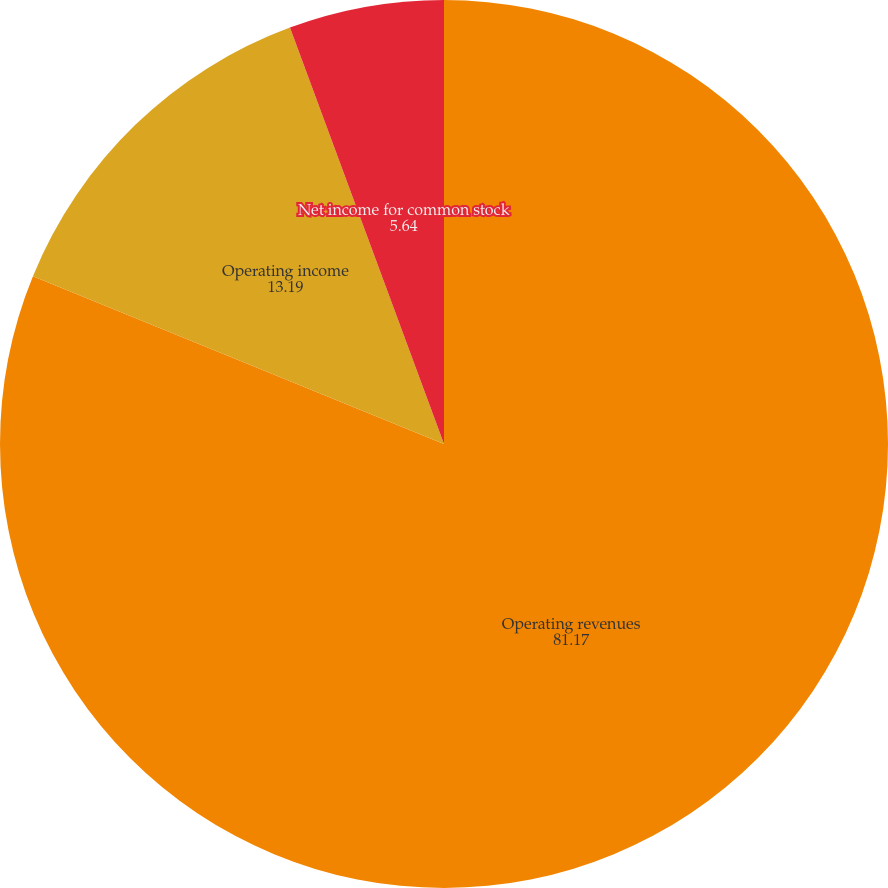Convert chart. <chart><loc_0><loc_0><loc_500><loc_500><pie_chart><fcel>Operating revenues<fcel>Operating income<fcel>Net income for common stock<nl><fcel>81.17%<fcel>13.19%<fcel>5.64%<nl></chart> 